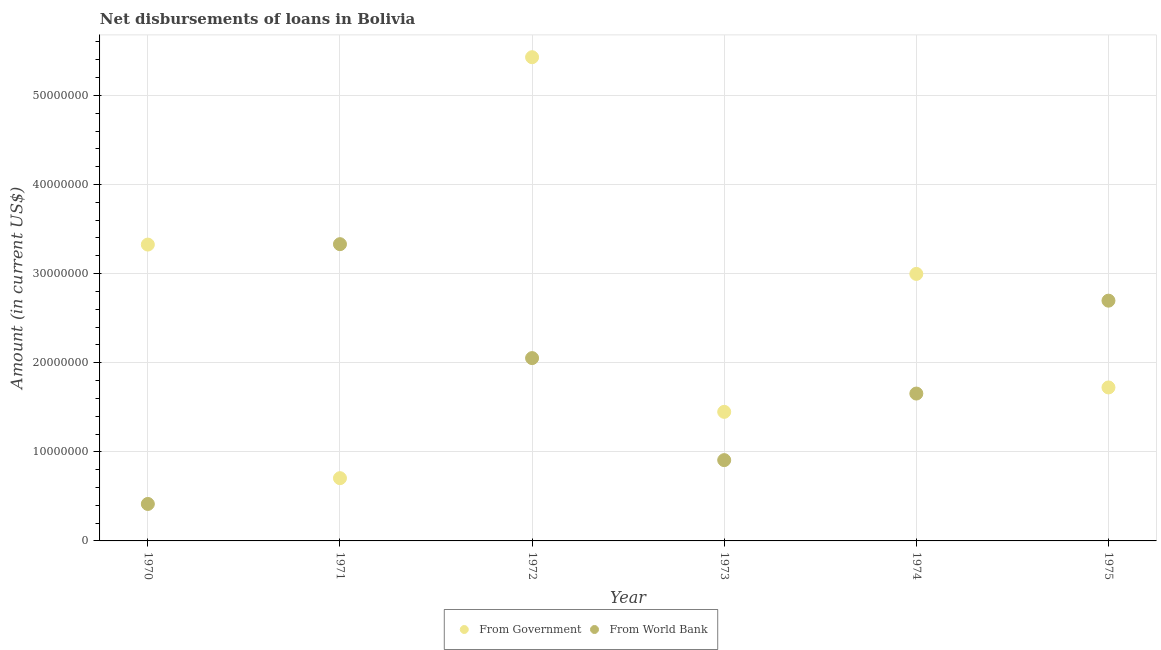Is the number of dotlines equal to the number of legend labels?
Your answer should be very brief. Yes. What is the net disbursements of loan from government in 1973?
Provide a succinct answer. 1.45e+07. Across all years, what is the maximum net disbursements of loan from world bank?
Make the answer very short. 3.33e+07. Across all years, what is the minimum net disbursements of loan from world bank?
Offer a very short reply. 4.15e+06. In which year was the net disbursements of loan from world bank maximum?
Provide a short and direct response. 1971. In which year was the net disbursements of loan from world bank minimum?
Your response must be concise. 1970. What is the total net disbursements of loan from government in the graph?
Your response must be concise. 1.56e+08. What is the difference between the net disbursements of loan from government in 1971 and that in 1975?
Your answer should be very brief. -1.02e+07. What is the difference between the net disbursements of loan from world bank in 1974 and the net disbursements of loan from government in 1970?
Ensure brevity in your answer.  -1.67e+07. What is the average net disbursements of loan from world bank per year?
Offer a terse response. 1.84e+07. In the year 1972, what is the difference between the net disbursements of loan from government and net disbursements of loan from world bank?
Your answer should be compact. 3.38e+07. What is the ratio of the net disbursements of loan from world bank in 1970 to that in 1974?
Your answer should be compact. 0.25. Is the difference between the net disbursements of loan from world bank in 1971 and 1974 greater than the difference between the net disbursements of loan from government in 1971 and 1974?
Your response must be concise. Yes. What is the difference between the highest and the second highest net disbursements of loan from government?
Your answer should be compact. 2.10e+07. What is the difference between the highest and the lowest net disbursements of loan from government?
Make the answer very short. 4.72e+07. Is the net disbursements of loan from government strictly less than the net disbursements of loan from world bank over the years?
Give a very brief answer. No. How many dotlines are there?
Make the answer very short. 2. Does the graph contain any zero values?
Your answer should be very brief. No. How are the legend labels stacked?
Offer a very short reply. Horizontal. What is the title of the graph?
Offer a very short reply. Net disbursements of loans in Bolivia. Does "Investments" appear as one of the legend labels in the graph?
Ensure brevity in your answer.  No. What is the label or title of the Y-axis?
Provide a short and direct response. Amount (in current US$). What is the Amount (in current US$) in From Government in 1970?
Provide a short and direct response. 3.33e+07. What is the Amount (in current US$) of From World Bank in 1970?
Provide a succinct answer. 4.15e+06. What is the Amount (in current US$) in From Government in 1971?
Provide a short and direct response. 7.04e+06. What is the Amount (in current US$) in From World Bank in 1971?
Make the answer very short. 3.33e+07. What is the Amount (in current US$) of From Government in 1972?
Give a very brief answer. 5.43e+07. What is the Amount (in current US$) in From World Bank in 1972?
Keep it short and to the point. 2.05e+07. What is the Amount (in current US$) in From Government in 1973?
Your response must be concise. 1.45e+07. What is the Amount (in current US$) in From World Bank in 1973?
Your response must be concise. 9.07e+06. What is the Amount (in current US$) in From Government in 1974?
Your answer should be compact. 3.00e+07. What is the Amount (in current US$) of From World Bank in 1974?
Your response must be concise. 1.65e+07. What is the Amount (in current US$) of From Government in 1975?
Provide a succinct answer. 1.72e+07. What is the Amount (in current US$) of From World Bank in 1975?
Offer a terse response. 2.70e+07. Across all years, what is the maximum Amount (in current US$) in From Government?
Offer a terse response. 5.43e+07. Across all years, what is the maximum Amount (in current US$) of From World Bank?
Provide a succinct answer. 3.33e+07. Across all years, what is the minimum Amount (in current US$) in From Government?
Offer a terse response. 7.04e+06. Across all years, what is the minimum Amount (in current US$) in From World Bank?
Ensure brevity in your answer.  4.15e+06. What is the total Amount (in current US$) in From Government in the graph?
Your answer should be compact. 1.56e+08. What is the total Amount (in current US$) in From World Bank in the graph?
Keep it short and to the point. 1.11e+08. What is the difference between the Amount (in current US$) in From Government in 1970 and that in 1971?
Provide a short and direct response. 2.62e+07. What is the difference between the Amount (in current US$) in From World Bank in 1970 and that in 1971?
Your answer should be very brief. -2.92e+07. What is the difference between the Amount (in current US$) of From Government in 1970 and that in 1972?
Your response must be concise. -2.10e+07. What is the difference between the Amount (in current US$) of From World Bank in 1970 and that in 1972?
Offer a terse response. -1.64e+07. What is the difference between the Amount (in current US$) in From Government in 1970 and that in 1973?
Provide a succinct answer. 1.88e+07. What is the difference between the Amount (in current US$) of From World Bank in 1970 and that in 1973?
Provide a short and direct response. -4.92e+06. What is the difference between the Amount (in current US$) in From Government in 1970 and that in 1974?
Keep it short and to the point. 3.29e+06. What is the difference between the Amount (in current US$) of From World Bank in 1970 and that in 1974?
Make the answer very short. -1.24e+07. What is the difference between the Amount (in current US$) of From Government in 1970 and that in 1975?
Make the answer very short. 1.60e+07. What is the difference between the Amount (in current US$) in From World Bank in 1970 and that in 1975?
Ensure brevity in your answer.  -2.28e+07. What is the difference between the Amount (in current US$) of From Government in 1971 and that in 1972?
Offer a terse response. -4.72e+07. What is the difference between the Amount (in current US$) of From World Bank in 1971 and that in 1972?
Provide a short and direct response. 1.28e+07. What is the difference between the Amount (in current US$) of From Government in 1971 and that in 1973?
Offer a very short reply. -7.44e+06. What is the difference between the Amount (in current US$) of From World Bank in 1971 and that in 1973?
Your response must be concise. 2.42e+07. What is the difference between the Amount (in current US$) of From Government in 1971 and that in 1974?
Offer a very short reply. -2.29e+07. What is the difference between the Amount (in current US$) of From World Bank in 1971 and that in 1974?
Make the answer very short. 1.68e+07. What is the difference between the Amount (in current US$) of From Government in 1971 and that in 1975?
Your answer should be very brief. -1.02e+07. What is the difference between the Amount (in current US$) in From World Bank in 1971 and that in 1975?
Your answer should be very brief. 6.34e+06. What is the difference between the Amount (in current US$) of From Government in 1972 and that in 1973?
Keep it short and to the point. 3.98e+07. What is the difference between the Amount (in current US$) of From World Bank in 1972 and that in 1973?
Make the answer very short. 1.14e+07. What is the difference between the Amount (in current US$) of From Government in 1972 and that in 1974?
Give a very brief answer. 2.43e+07. What is the difference between the Amount (in current US$) in From World Bank in 1972 and that in 1974?
Provide a short and direct response. 3.98e+06. What is the difference between the Amount (in current US$) of From Government in 1972 and that in 1975?
Your answer should be very brief. 3.71e+07. What is the difference between the Amount (in current US$) in From World Bank in 1972 and that in 1975?
Your answer should be compact. -6.45e+06. What is the difference between the Amount (in current US$) of From Government in 1973 and that in 1974?
Provide a short and direct response. -1.55e+07. What is the difference between the Amount (in current US$) in From World Bank in 1973 and that in 1974?
Keep it short and to the point. -7.47e+06. What is the difference between the Amount (in current US$) in From Government in 1973 and that in 1975?
Your answer should be compact. -2.74e+06. What is the difference between the Amount (in current US$) of From World Bank in 1973 and that in 1975?
Offer a terse response. -1.79e+07. What is the difference between the Amount (in current US$) in From Government in 1974 and that in 1975?
Your answer should be very brief. 1.27e+07. What is the difference between the Amount (in current US$) of From World Bank in 1974 and that in 1975?
Your response must be concise. -1.04e+07. What is the difference between the Amount (in current US$) in From Government in 1970 and the Amount (in current US$) in From World Bank in 1971?
Provide a short and direct response. -4.50e+04. What is the difference between the Amount (in current US$) in From Government in 1970 and the Amount (in current US$) in From World Bank in 1972?
Give a very brief answer. 1.27e+07. What is the difference between the Amount (in current US$) of From Government in 1970 and the Amount (in current US$) of From World Bank in 1973?
Your response must be concise. 2.42e+07. What is the difference between the Amount (in current US$) of From Government in 1970 and the Amount (in current US$) of From World Bank in 1974?
Keep it short and to the point. 1.67e+07. What is the difference between the Amount (in current US$) of From Government in 1970 and the Amount (in current US$) of From World Bank in 1975?
Give a very brief answer. 6.30e+06. What is the difference between the Amount (in current US$) in From Government in 1971 and the Amount (in current US$) in From World Bank in 1972?
Offer a terse response. -1.35e+07. What is the difference between the Amount (in current US$) in From Government in 1971 and the Amount (in current US$) in From World Bank in 1973?
Offer a terse response. -2.03e+06. What is the difference between the Amount (in current US$) in From Government in 1971 and the Amount (in current US$) in From World Bank in 1974?
Offer a very short reply. -9.50e+06. What is the difference between the Amount (in current US$) of From Government in 1971 and the Amount (in current US$) of From World Bank in 1975?
Provide a short and direct response. -1.99e+07. What is the difference between the Amount (in current US$) in From Government in 1972 and the Amount (in current US$) in From World Bank in 1973?
Your response must be concise. 4.52e+07. What is the difference between the Amount (in current US$) of From Government in 1972 and the Amount (in current US$) of From World Bank in 1974?
Make the answer very short. 3.78e+07. What is the difference between the Amount (in current US$) of From Government in 1972 and the Amount (in current US$) of From World Bank in 1975?
Your answer should be compact. 2.73e+07. What is the difference between the Amount (in current US$) of From Government in 1973 and the Amount (in current US$) of From World Bank in 1974?
Provide a succinct answer. -2.05e+06. What is the difference between the Amount (in current US$) in From Government in 1973 and the Amount (in current US$) in From World Bank in 1975?
Provide a short and direct response. -1.25e+07. What is the difference between the Amount (in current US$) in From Government in 1974 and the Amount (in current US$) in From World Bank in 1975?
Provide a short and direct response. 3.00e+06. What is the average Amount (in current US$) in From Government per year?
Ensure brevity in your answer.  2.60e+07. What is the average Amount (in current US$) in From World Bank per year?
Your answer should be compact. 1.84e+07. In the year 1970, what is the difference between the Amount (in current US$) in From Government and Amount (in current US$) in From World Bank?
Give a very brief answer. 2.91e+07. In the year 1971, what is the difference between the Amount (in current US$) of From Government and Amount (in current US$) of From World Bank?
Your answer should be compact. -2.63e+07. In the year 1972, what is the difference between the Amount (in current US$) of From Government and Amount (in current US$) of From World Bank?
Offer a very short reply. 3.38e+07. In the year 1973, what is the difference between the Amount (in current US$) in From Government and Amount (in current US$) in From World Bank?
Your response must be concise. 5.42e+06. In the year 1974, what is the difference between the Amount (in current US$) in From Government and Amount (in current US$) in From World Bank?
Your answer should be compact. 1.34e+07. In the year 1975, what is the difference between the Amount (in current US$) in From Government and Amount (in current US$) in From World Bank?
Keep it short and to the point. -9.74e+06. What is the ratio of the Amount (in current US$) of From Government in 1970 to that in 1971?
Give a very brief answer. 4.72. What is the ratio of the Amount (in current US$) of From World Bank in 1970 to that in 1971?
Provide a succinct answer. 0.12. What is the ratio of the Amount (in current US$) in From Government in 1970 to that in 1972?
Ensure brevity in your answer.  0.61. What is the ratio of the Amount (in current US$) of From World Bank in 1970 to that in 1972?
Your answer should be very brief. 0.2. What is the ratio of the Amount (in current US$) in From Government in 1970 to that in 1973?
Give a very brief answer. 2.3. What is the ratio of the Amount (in current US$) in From World Bank in 1970 to that in 1973?
Make the answer very short. 0.46. What is the ratio of the Amount (in current US$) in From Government in 1970 to that in 1974?
Provide a short and direct response. 1.11. What is the ratio of the Amount (in current US$) of From World Bank in 1970 to that in 1974?
Provide a short and direct response. 0.25. What is the ratio of the Amount (in current US$) of From Government in 1970 to that in 1975?
Offer a terse response. 1.93. What is the ratio of the Amount (in current US$) in From World Bank in 1970 to that in 1975?
Offer a very short reply. 0.15. What is the ratio of the Amount (in current US$) in From Government in 1971 to that in 1972?
Provide a succinct answer. 0.13. What is the ratio of the Amount (in current US$) in From World Bank in 1971 to that in 1972?
Provide a succinct answer. 1.62. What is the ratio of the Amount (in current US$) of From Government in 1971 to that in 1973?
Offer a very short reply. 0.49. What is the ratio of the Amount (in current US$) in From World Bank in 1971 to that in 1973?
Offer a very short reply. 3.67. What is the ratio of the Amount (in current US$) in From Government in 1971 to that in 1974?
Provide a short and direct response. 0.23. What is the ratio of the Amount (in current US$) in From World Bank in 1971 to that in 1974?
Offer a very short reply. 2.01. What is the ratio of the Amount (in current US$) in From Government in 1971 to that in 1975?
Keep it short and to the point. 0.41. What is the ratio of the Amount (in current US$) in From World Bank in 1971 to that in 1975?
Offer a very short reply. 1.24. What is the ratio of the Amount (in current US$) in From Government in 1972 to that in 1973?
Offer a terse response. 3.75. What is the ratio of the Amount (in current US$) of From World Bank in 1972 to that in 1973?
Provide a short and direct response. 2.26. What is the ratio of the Amount (in current US$) in From Government in 1972 to that in 1974?
Provide a short and direct response. 1.81. What is the ratio of the Amount (in current US$) of From World Bank in 1972 to that in 1974?
Offer a very short reply. 1.24. What is the ratio of the Amount (in current US$) of From Government in 1972 to that in 1975?
Keep it short and to the point. 3.15. What is the ratio of the Amount (in current US$) in From World Bank in 1972 to that in 1975?
Your response must be concise. 0.76. What is the ratio of the Amount (in current US$) of From Government in 1973 to that in 1974?
Offer a very short reply. 0.48. What is the ratio of the Amount (in current US$) in From World Bank in 1973 to that in 1974?
Ensure brevity in your answer.  0.55. What is the ratio of the Amount (in current US$) of From Government in 1973 to that in 1975?
Provide a succinct answer. 0.84. What is the ratio of the Amount (in current US$) in From World Bank in 1973 to that in 1975?
Offer a very short reply. 0.34. What is the ratio of the Amount (in current US$) in From Government in 1974 to that in 1975?
Ensure brevity in your answer.  1.74. What is the ratio of the Amount (in current US$) in From World Bank in 1974 to that in 1975?
Ensure brevity in your answer.  0.61. What is the difference between the highest and the second highest Amount (in current US$) of From Government?
Your answer should be compact. 2.10e+07. What is the difference between the highest and the second highest Amount (in current US$) of From World Bank?
Give a very brief answer. 6.34e+06. What is the difference between the highest and the lowest Amount (in current US$) of From Government?
Keep it short and to the point. 4.72e+07. What is the difference between the highest and the lowest Amount (in current US$) in From World Bank?
Ensure brevity in your answer.  2.92e+07. 